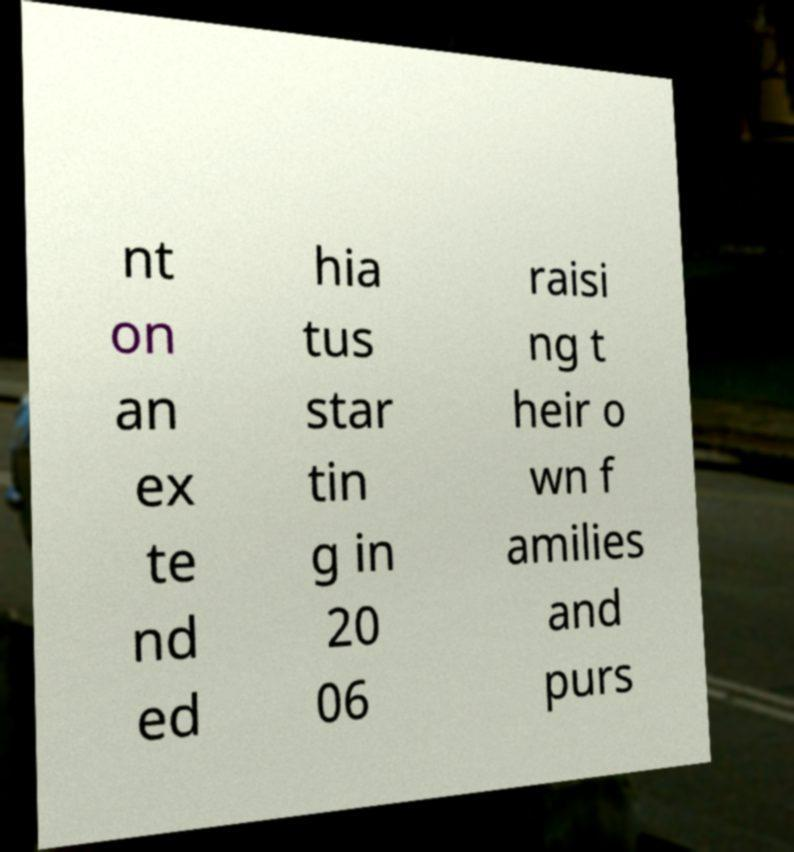Can you accurately transcribe the text from the provided image for me? nt on an ex te nd ed hia tus star tin g in 20 06 raisi ng t heir o wn f amilies and purs 